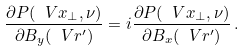<formula> <loc_0><loc_0><loc_500><loc_500>\frac { \partial P ( \ V { x } _ { \perp } , \nu ) } { \partial B _ { y } ( { \ V { r } ^ { \prime } } ) } = i \frac { \partial P ( \ V { x } _ { \perp } , \nu ) } { \partial B _ { x } ( { \ V { r } ^ { \prime } } ) } \, .</formula> 